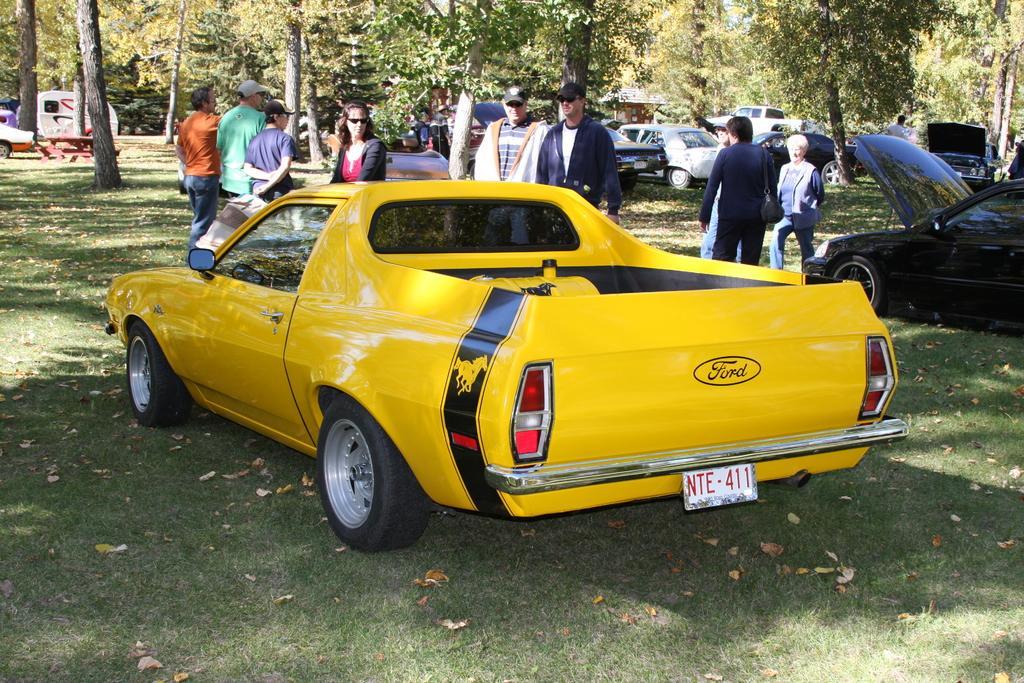Please provide a concise description of this image. In this image, there are a few vehicles, trees and people. We can see the ground with some grass and some benches. We can also see a white colored object. 